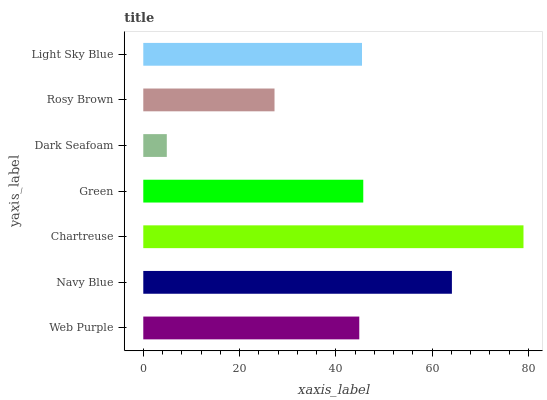Is Dark Seafoam the minimum?
Answer yes or no. Yes. Is Chartreuse the maximum?
Answer yes or no. Yes. Is Navy Blue the minimum?
Answer yes or no. No. Is Navy Blue the maximum?
Answer yes or no. No. Is Navy Blue greater than Web Purple?
Answer yes or no. Yes. Is Web Purple less than Navy Blue?
Answer yes or no. Yes. Is Web Purple greater than Navy Blue?
Answer yes or no. No. Is Navy Blue less than Web Purple?
Answer yes or no. No. Is Light Sky Blue the high median?
Answer yes or no. Yes. Is Light Sky Blue the low median?
Answer yes or no. Yes. Is Navy Blue the high median?
Answer yes or no. No. Is Navy Blue the low median?
Answer yes or no. No. 